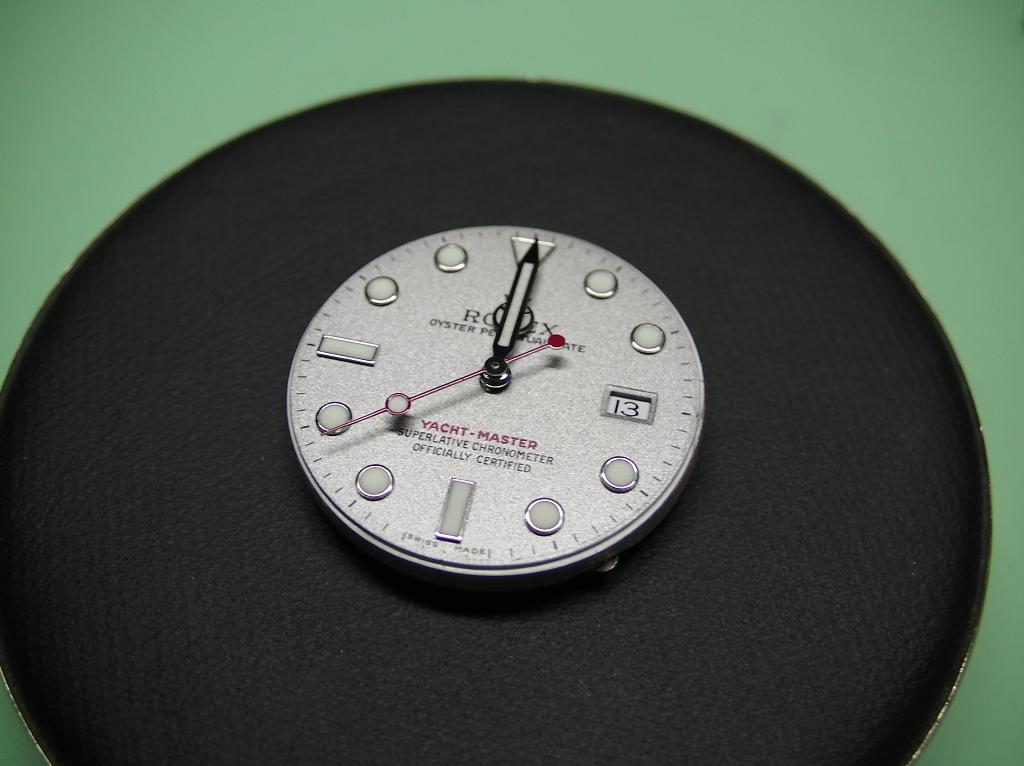What time is it on the clock?
Provide a short and direct response. 12:00. 